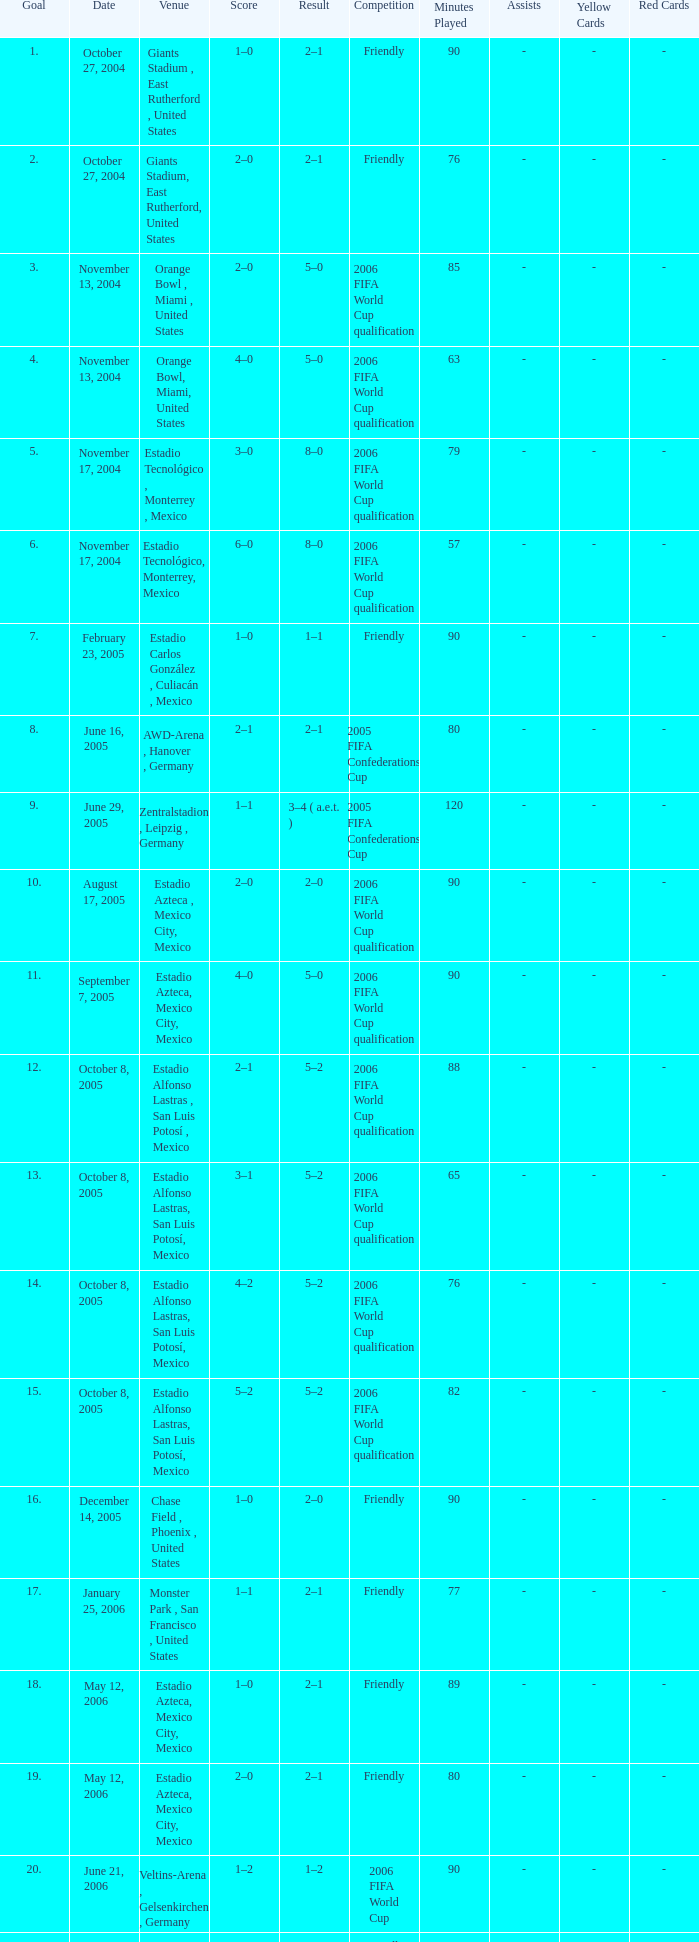Which Competition has a Venue of estadio alfonso lastras, san luis potosí, mexico, and a Goal larger than 15? Friendly. 